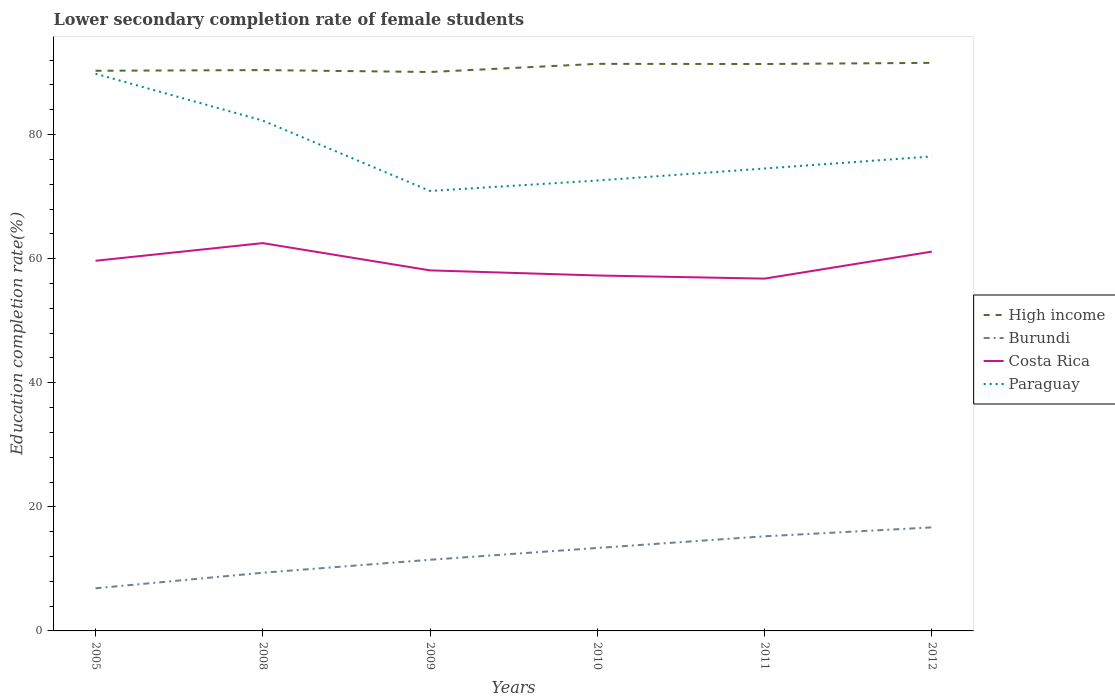How many different coloured lines are there?
Give a very brief answer. 4. Does the line corresponding to Burundi intersect with the line corresponding to High income?
Offer a terse response. No. Is the number of lines equal to the number of legend labels?
Your answer should be compact. Yes. Across all years, what is the maximum lower secondary completion rate of female students in Costa Rica?
Keep it short and to the point. 56.79. In which year was the lower secondary completion rate of female students in Paraguay maximum?
Offer a terse response. 2009. What is the total lower secondary completion rate of female students in Burundi in the graph?
Your answer should be very brief. -3.31. What is the difference between the highest and the second highest lower secondary completion rate of female students in Costa Rica?
Provide a succinct answer. 5.72. What is the difference between the highest and the lowest lower secondary completion rate of female students in Costa Rica?
Ensure brevity in your answer.  3. Is the lower secondary completion rate of female students in High income strictly greater than the lower secondary completion rate of female students in Costa Rica over the years?
Give a very brief answer. No. How many lines are there?
Keep it short and to the point. 4. What is the difference between two consecutive major ticks on the Y-axis?
Ensure brevity in your answer.  20. Does the graph contain any zero values?
Make the answer very short. No. Where does the legend appear in the graph?
Your response must be concise. Center right. How many legend labels are there?
Your answer should be very brief. 4. How are the legend labels stacked?
Your answer should be very brief. Vertical. What is the title of the graph?
Provide a succinct answer. Lower secondary completion rate of female students. Does "Guatemala" appear as one of the legend labels in the graph?
Your answer should be very brief. No. What is the label or title of the Y-axis?
Your response must be concise. Education completion rate(%). What is the Education completion rate(%) in High income in 2005?
Provide a succinct answer. 90.3. What is the Education completion rate(%) of Burundi in 2005?
Your answer should be very brief. 6.87. What is the Education completion rate(%) in Costa Rica in 2005?
Keep it short and to the point. 59.67. What is the Education completion rate(%) in Paraguay in 2005?
Make the answer very short. 89.81. What is the Education completion rate(%) of High income in 2008?
Your answer should be compact. 90.4. What is the Education completion rate(%) in Burundi in 2008?
Ensure brevity in your answer.  9.38. What is the Education completion rate(%) of Costa Rica in 2008?
Make the answer very short. 62.51. What is the Education completion rate(%) in Paraguay in 2008?
Offer a very short reply. 82.26. What is the Education completion rate(%) of High income in 2009?
Keep it short and to the point. 90.1. What is the Education completion rate(%) of Burundi in 2009?
Ensure brevity in your answer.  11.47. What is the Education completion rate(%) of Costa Rica in 2009?
Your answer should be very brief. 58.12. What is the Education completion rate(%) in Paraguay in 2009?
Your response must be concise. 70.92. What is the Education completion rate(%) in High income in 2010?
Your answer should be very brief. 91.41. What is the Education completion rate(%) in Burundi in 2010?
Give a very brief answer. 13.37. What is the Education completion rate(%) of Costa Rica in 2010?
Provide a succinct answer. 57.3. What is the Education completion rate(%) in Paraguay in 2010?
Keep it short and to the point. 72.6. What is the Education completion rate(%) of High income in 2011?
Ensure brevity in your answer.  91.38. What is the Education completion rate(%) of Burundi in 2011?
Provide a short and direct response. 15.25. What is the Education completion rate(%) in Costa Rica in 2011?
Provide a succinct answer. 56.79. What is the Education completion rate(%) in Paraguay in 2011?
Your response must be concise. 74.54. What is the Education completion rate(%) in High income in 2012?
Your response must be concise. 91.57. What is the Education completion rate(%) of Burundi in 2012?
Keep it short and to the point. 16.69. What is the Education completion rate(%) of Costa Rica in 2012?
Offer a very short reply. 61.14. What is the Education completion rate(%) of Paraguay in 2012?
Ensure brevity in your answer.  76.48. Across all years, what is the maximum Education completion rate(%) of High income?
Provide a short and direct response. 91.57. Across all years, what is the maximum Education completion rate(%) of Burundi?
Your answer should be very brief. 16.69. Across all years, what is the maximum Education completion rate(%) in Costa Rica?
Your answer should be very brief. 62.51. Across all years, what is the maximum Education completion rate(%) of Paraguay?
Offer a terse response. 89.81. Across all years, what is the minimum Education completion rate(%) of High income?
Offer a terse response. 90.1. Across all years, what is the minimum Education completion rate(%) in Burundi?
Give a very brief answer. 6.87. Across all years, what is the minimum Education completion rate(%) of Costa Rica?
Make the answer very short. 56.79. Across all years, what is the minimum Education completion rate(%) in Paraguay?
Your answer should be very brief. 70.92. What is the total Education completion rate(%) of High income in the graph?
Keep it short and to the point. 545.16. What is the total Education completion rate(%) of Burundi in the graph?
Offer a very short reply. 73.04. What is the total Education completion rate(%) in Costa Rica in the graph?
Offer a very short reply. 355.52. What is the total Education completion rate(%) in Paraguay in the graph?
Your answer should be compact. 466.62. What is the difference between the Education completion rate(%) of High income in 2005 and that in 2008?
Keep it short and to the point. -0.11. What is the difference between the Education completion rate(%) in Burundi in 2005 and that in 2008?
Offer a terse response. -2.5. What is the difference between the Education completion rate(%) of Costa Rica in 2005 and that in 2008?
Offer a very short reply. -2.84. What is the difference between the Education completion rate(%) in Paraguay in 2005 and that in 2008?
Provide a succinct answer. 7.55. What is the difference between the Education completion rate(%) in High income in 2005 and that in 2009?
Provide a succinct answer. 0.2. What is the difference between the Education completion rate(%) in Burundi in 2005 and that in 2009?
Provide a succinct answer. -4.6. What is the difference between the Education completion rate(%) in Costa Rica in 2005 and that in 2009?
Make the answer very short. 1.55. What is the difference between the Education completion rate(%) of Paraguay in 2005 and that in 2009?
Your response must be concise. 18.89. What is the difference between the Education completion rate(%) in High income in 2005 and that in 2010?
Offer a terse response. -1.11. What is the difference between the Education completion rate(%) in Burundi in 2005 and that in 2010?
Your answer should be compact. -6.5. What is the difference between the Education completion rate(%) in Costa Rica in 2005 and that in 2010?
Your answer should be compact. 2.37. What is the difference between the Education completion rate(%) of Paraguay in 2005 and that in 2010?
Make the answer very short. 17.21. What is the difference between the Education completion rate(%) in High income in 2005 and that in 2011?
Ensure brevity in your answer.  -1.09. What is the difference between the Education completion rate(%) in Burundi in 2005 and that in 2011?
Ensure brevity in your answer.  -8.38. What is the difference between the Education completion rate(%) in Costa Rica in 2005 and that in 2011?
Ensure brevity in your answer.  2.88. What is the difference between the Education completion rate(%) in Paraguay in 2005 and that in 2011?
Your response must be concise. 15.27. What is the difference between the Education completion rate(%) of High income in 2005 and that in 2012?
Provide a succinct answer. -1.27. What is the difference between the Education completion rate(%) in Burundi in 2005 and that in 2012?
Offer a terse response. -9.81. What is the difference between the Education completion rate(%) of Costa Rica in 2005 and that in 2012?
Offer a very short reply. -1.47. What is the difference between the Education completion rate(%) in Paraguay in 2005 and that in 2012?
Offer a terse response. 13.33. What is the difference between the Education completion rate(%) of High income in 2008 and that in 2009?
Keep it short and to the point. 0.31. What is the difference between the Education completion rate(%) in Burundi in 2008 and that in 2009?
Make the answer very short. -2.09. What is the difference between the Education completion rate(%) of Costa Rica in 2008 and that in 2009?
Provide a succinct answer. 4.39. What is the difference between the Education completion rate(%) in Paraguay in 2008 and that in 2009?
Your answer should be compact. 11.34. What is the difference between the Education completion rate(%) of High income in 2008 and that in 2010?
Make the answer very short. -1.01. What is the difference between the Education completion rate(%) of Burundi in 2008 and that in 2010?
Give a very brief answer. -4. What is the difference between the Education completion rate(%) of Costa Rica in 2008 and that in 2010?
Your answer should be compact. 5.22. What is the difference between the Education completion rate(%) in Paraguay in 2008 and that in 2010?
Make the answer very short. 9.66. What is the difference between the Education completion rate(%) of High income in 2008 and that in 2011?
Keep it short and to the point. -0.98. What is the difference between the Education completion rate(%) of Burundi in 2008 and that in 2011?
Offer a very short reply. -5.88. What is the difference between the Education completion rate(%) of Costa Rica in 2008 and that in 2011?
Your answer should be compact. 5.72. What is the difference between the Education completion rate(%) in Paraguay in 2008 and that in 2011?
Provide a succinct answer. 7.72. What is the difference between the Education completion rate(%) in High income in 2008 and that in 2012?
Offer a terse response. -1.17. What is the difference between the Education completion rate(%) in Burundi in 2008 and that in 2012?
Provide a succinct answer. -7.31. What is the difference between the Education completion rate(%) of Costa Rica in 2008 and that in 2012?
Ensure brevity in your answer.  1.37. What is the difference between the Education completion rate(%) in Paraguay in 2008 and that in 2012?
Provide a succinct answer. 5.78. What is the difference between the Education completion rate(%) in High income in 2009 and that in 2010?
Keep it short and to the point. -1.31. What is the difference between the Education completion rate(%) in Burundi in 2009 and that in 2010?
Your response must be concise. -1.9. What is the difference between the Education completion rate(%) of Costa Rica in 2009 and that in 2010?
Your answer should be very brief. 0.82. What is the difference between the Education completion rate(%) in Paraguay in 2009 and that in 2010?
Make the answer very short. -1.68. What is the difference between the Education completion rate(%) in High income in 2009 and that in 2011?
Offer a very short reply. -1.29. What is the difference between the Education completion rate(%) in Burundi in 2009 and that in 2011?
Provide a short and direct response. -3.78. What is the difference between the Education completion rate(%) in Costa Rica in 2009 and that in 2011?
Your response must be concise. 1.33. What is the difference between the Education completion rate(%) in Paraguay in 2009 and that in 2011?
Offer a very short reply. -3.62. What is the difference between the Education completion rate(%) in High income in 2009 and that in 2012?
Ensure brevity in your answer.  -1.48. What is the difference between the Education completion rate(%) in Burundi in 2009 and that in 2012?
Your answer should be compact. -5.22. What is the difference between the Education completion rate(%) of Costa Rica in 2009 and that in 2012?
Offer a very short reply. -3.02. What is the difference between the Education completion rate(%) in Paraguay in 2009 and that in 2012?
Your response must be concise. -5.56. What is the difference between the Education completion rate(%) of High income in 2010 and that in 2011?
Offer a very short reply. 0.03. What is the difference between the Education completion rate(%) in Burundi in 2010 and that in 2011?
Your answer should be very brief. -1.88. What is the difference between the Education completion rate(%) of Costa Rica in 2010 and that in 2011?
Keep it short and to the point. 0.51. What is the difference between the Education completion rate(%) in Paraguay in 2010 and that in 2011?
Provide a succinct answer. -1.94. What is the difference between the Education completion rate(%) in High income in 2010 and that in 2012?
Offer a terse response. -0.16. What is the difference between the Education completion rate(%) in Burundi in 2010 and that in 2012?
Offer a terse response. -3.31. What is the difference between the Education completion rate(%) in Costa Rica in 2010 and that in 2012?
Keep it short and to the point. -3.85. What is the difference between the Education completion rate(%) in Paraguay in 2010 and that in 2012?
Provide a succinct answer. -3.88. What is the difference between the Education completion rate(%) in High income in 2011 and that in 2012?
Give a very brief answer. -0.19. What is the difference between the Education completion rate(%) in Burundi in 2011 and that in 2012?
Your answer should be very brief. -1.43. What is the difference between the Education completion rate(%) in Costa Rica in 2011 and that in 2012?
Your answer should be compact. -4.35. What is the difference between the Education completion rate(%) in Paraguay in 2011 and that in 2012?
Give a very brief answer. -1.94. What is the difference between the Education completion rate(%) of High income in 2005 and the Education completion rate(%) of Burundi in 2008?
Keep it short and to the point. 80.92. What is the difference between the Education completion rate(%) of High income in 2005 and the Education completion rate(%) of Costa Rica in 2008?
Your answer should be very brief. 27.79. What is the difference between the Education completion rate(%) of High income in 2005 and the Education completion rate(%) of Paraguay in 2008?
Provide a succinct answer. 8.03. What is the difference between the Education completion rate(%) in Burundi in 2005 and the Education completion rate(%) in Costa Rica in 2008?
Make the answer very short. -55.64. What is the difference between the Education completion rate(%) in Burundi in 2005 and the Education completion rate(%) in Paraguay in 2008?
Provide a short and direct response. -75.39. What is the difference between the Education completion rate(%) in Costa Rica in 2005 and the Education completion rate(%) in Paraguay in 2008?
Provide a short and direct response. -22.6. What is the difference between the Education completion rate(%) in High income in 2005 and the Education completion rate(%) in Burundi in 2009?
Make the answer very short. 78.83. What is the difference between the Education completion rate(%) of High income in 2005 and the Education completion rate(%) of Costa Rica in 2009?
Your answer should be compact. 32.18. What is the difference between the Education completion rate(%) of High income in 2005 and the Education completion rate(%) of Paraguay in 2009?
Your answer should be very brief. 19.37. What is the difference between the Education completion rate(%) in Burundi in 2005 and the Education completion rate(%) in Costa Rica in 2009?
Make the answer very short. -51.24. What is the difference between the Education completion rate(%) in Burundi in 2005 and the Education completion rate(%) in Paraguay in 2009?
Provide a succinct answer. -64.05. What is the difference between the Education completion rate(%) in Costa Rica in 2005 and the Education completion rate(%) in Paraguay in 2009?
Your answer should be compact. -11.26. What is the difference between the Education completion rate(%) in High income in 2005 and the Education completion rate(%) in Burundi in 2010?
Make the answer very short. 76.92. What is the difference between the Education completion rate(%) of High income in 2005 and the Education completion rate(%) of Costa Rica in 2010?
Keep it short and to the point. 33. What is the difference between the Education completion rate(%) of High income in 2005 and the Education completion rate(%) of Paraguay in 2010?
Your answer should be very brief. 17.69. What is the difference between the Education completion rate(%) in Burundi in 2005 and the Education completion rate(%) in Costa Rica in 2010?
Ensure brevity in your answer.  -50.42. What is the difference between the Education completion rate(%) in Burundi in 2005 and the Education completion rate(%) in Paraguay in 2010?
Your answer should be compact. -65.73. What is the difference between the Education completion rate(%) in Costa Rica in 2005 and the Education completion rate(%) in Paraguay in 2010?
Offer a terse response. -12.93. What is the difference between the Education completion rate(%) in High income in 2005 and the Education completion rate(%) in Burundi in 2011?
Provide a succinct answer. 75.04. What is the difference between the Education completion rate(%) in High income in 2005 and the Education completion rate(%) in Costa Rica in 2011?
Your response must be concise. 33.51. What is the difference between the Education completion rate(%) of High income in 2005 and the Education completion rate(%) of Paraguay in 2011?
Make the answer very short. 15.76. What is the difference between the Education completion rate(%) in Burundi in 2005 and the Education completion rate(%) in Costa Rica in 2011?
Your answer should be very brief. -49.91. What is the difference between the Education completion rate(%) in Burundi in 2005 and the Education completion rate(%) in Paraguay in 2011?
Your answer should be very brief. -67.67. What is the difference between the Education completion rate(%) of Costa Rica in 2005 and the Education completion rate(%) of Paraguay in 2011?
Your answer should be very brief. -14.87. What is the difference between the Education completion rate(%) of High income in 2005 and the Education completion rate(%) of Burundi in 2012?
Your answer should be compact. 73.61. What is the difference between the Education completion rate(%) of High income in 2005 and the Education completion rate(%) of Costa Rica in 2012?
Keep it short and to the point. 29.15. What is the difference between the Education completion rate(%) in High income in 2005 and the Education completion rate(%) in Paraguay in 2012?
Provide a short and direct response. 13.81. What is the difference between the Education completion rate(%) in Burundi in 2005 and the Education completion rate(%) in Costa Rica in 2012?
Provide a short and direct response. -54.27. What is the difference between the Education completion rate(%) of Burundi in 2005 and the Education completion rate(%) of Paraguay in 2012?
Give a very brief answer. -69.61. What is the difference between the Education completion rate(%) in Costa Rica in 2005 and the Education completion rate(%) in Paraguay in 2012?
Make the answer very short. -16.81. What is the difference between the Education completion rate(%) of High income in 2008 and the Education completion rate(%) of Burundi in 2009?
Offer a very short reply. 78.93. What is the difference between the Education completion rate(%) of High income in 2008 and the Education completion rate(%) of Costa Rica in 2009?
Your answer should be very brief. 32.29. What is the difference between the Education completion rate(%) of High income in 2008 and the Education completion rate(%) of Paraguay in 2009?
Your answer should be very brief. 19.48. What is the difference between the Education completion rate(%) of Burundi in 2008 and the Education completion rate(%) of Costa Rica in 2009?
Offer a terse response. -48.74. What is the difference between the Education completion rate(%) in Burundi in 2008 and the Education completion rate(%) in Paraguay in 2009?
Keep it short and to the point. -61.55. What is the difference between the Education completion rate(%) of Costa Rica in 2008 and the Education completion rate(%) of Paraguay in 2009?
Ensure brevity in your answer.  -8.41. What is the difference between the Education completion rate(%) in High income in 2008 and the Education completion rate(%) in Burundi in 2010?
Your answer should be compact. 77.03. What is the difference between the Education completion rate(%) in High income in 2008 and the Education completion rate(%) in Costa Rica in 2010?
Your response must be concise. 33.11. What is the difference between the Education completion rate(%) in High income in 2008 and the Education completion rate(%) in Paraguay in 2010?
Give a very brief answer. 17.8. What is the difference between the Education completion rate(%) in Burundi in 2008 and the Education completion rate(%) in Costa Rica in 2010?
Offer a very short reply. -47.92. What is the difference between the Education completion rate(%) of Burundi in 2008 and the Education completion rate(%) of Paraguay in 2010?
Your response must be concise. -63.22. What is the difference between the Education completion rate(%) in Costa Rica in 2008 and the Education completion rate(%) in Paraguay in 2010?
Provide a short and direct response. -10.09. What is the difference between the Education completion rate(%) of High income in 2008 and the Education completion rate(%) of Burundi in 2011?
Your answer should be very brief. 75.15. What is the difference between the Education completion rate(%) of High income in 2008 and the Education completion rate(%) of Costa Rica in 2011?
Give a very brief answer. 33.62. What is the difference between the Education completion rate(%) in High income in 2008 and the Education completion rate(%) in Paraguay in 2011?
Make the answer very short. 15.86. What is the difference between the Education completion rate(%) of Burundi in 2008 and the Education completion rate(%) of Costa Rica in 2011?
Provide a succinct answer. -47.41. What is the difference between the Education completion rate(%) of Burundi in 2008 and the Education completion rate(%) of Paraguay in 2011?
Provide a short and direct response. -65.16. What is the difference between the Education completion rate(%) of Costa Rica in 2008 and the Education completion rate(%) of Paraguay in 2011?
Offer a terse response. -12.03. What is the difference between the Education completion rate(%) in High income in 2008 and the Education completion rate(%) in Burundi in 2012?
Provide a succinct answer. 73.72. What is the difference between the Education completion rate(%) of High income in 2008 and the Education completion rate(%) of Costa Rica in 2012?
Ensure brevity in your answer.  29.26. What is the difference between the Education completion rate(%) in High income in 2008 and the Education completion rate(%) in Paraguay in 2012?
Ensure brevity in your answer.  13.92. What is the difference between the Education completion rate(%) in Burundi in 2008 and the Education completion rate(%) in Costa Rica in 2012?
Provide a short and direct response. -51.76. What is the difference between the Education completion rate(%) of Burundi in 2008 and the Education completion rate(%) of Paraguay in 2012?
Provide a short and direct response. -67.1. What is the difference between the Education completion rate(%) in Costa Rica in 2008 and the Education completion rate(%) in Paraguay in 2012?
Provide a short and direct response. -13.97. What is the difference between the Education completion rate(%) of High income in 2009 and the Education completion rate(%) of Burundi in 2010?
Offer a very short reply. 76.72. What is the difference between the Education completion rate(%) in High income in 2009 and the Education completion rate(%) in Costa Rica in 2010?
Keep it short and to the point. 32.8. What is the difference between the Education completion rate(%) in High income in 2009 and the Education completion rate(%) in Paraguay in 2010?
Offer a very short reply. 17.49. What is the difference between the Education completion rate(%) of Burundi in 2009 and the Education completion rate(%) of Costa Rica in 2010?
Keep it short and to the point. -45.83. What is the difference between the Education completion rate(%) in Burundi in 2009 and the Education completion rate(%) in Paraguay in 2010?
Provide a succinct answer. -61.13. What is the difference between the Education completion rate(%) of Costa Rica in 2009 and the Education completion rate(%) of Paraguay in 2010?
Provide a short and direct response. -14.48. What is the difference between the Education completion rate(%) in High income in 2009 and the Education completion rate(%) in Burundi in 2011?
Ensure brevity in your answer.  74.84. What is the difference between the Education completion rate(%) in High income in 2009 and the Education completion rate(%) in Costa Rica in 2011?
Your response must be concise. 33.31. What is the difference between the Education completion rate(%) in High income in 2009 and the Education completion rate(%) in Paraguay in 2011?
Your answer should be very brief. 15.56. What is the difference between the Education completion rate(%) of Burundi in 2009 and the Education completion rate(%) of Costa Rica in 2011?
Give a very brief answer. -45.32. What is the difference between the Education completion rate(%) in Burundi in 2009 and the Education completion rate(%) in Paraguay in 2011?
Offer a very short reply. -63.07. What is the difference between the Education completion rate(%) in Costa Rica in 2009 and the Education completion rate(%) in Paraguay in 2011?
Your answer should be compact. -16.42. What is the difference between the Education completion rate(%) of High income in 2009 and the Education completion rate(%) of Burundi in 2012?
Offer a terse response. 73.41. What is the difference between the Education completion rate(%) of High income in 2009 and the Education completion rate(%) of Costa Rica in 2012?
Your answer should be very brief. 28.95. What is the difference between the Education completion rate(%) of High income in 2009 and the Education completion rate(%) of Paraguay in 2012?
Keep it short and to the point. 13.61. What is the difference between the Education completion rate(%) of Burundi in 2009 and the Education completion rate(%) of Costa Rica in 2012?
Your response must be concise. -49.67. What is the difference between the Education completion rate(%) in Burundi in 2009 and the Education completion rate(%) in Paraguay in 2012?
Your response must be concise. -65.01. What is the difference between the Education completion rate(%) of Costa Rica in 2009 and the Education completion rate(%) of Paraguay in 2012?
Your answer should be compact. -18.36. What is the difference between the Education completion rate(%) in High income in 2010 and the Education completion rate(%) in Burundi in 2011?
Provide a succinct answer. 76.16. What is the difference between the Education completion rate(%) in High income in 2010 and the Education completion rate(%) in Costa Rica in 2011?
Offer a terse response. 34.62. What is the difference between the Education completion rate(%) of High income in 2010 and the Education completion rate(%) of Paraguay in 2011?
Keep it short and to the point. 16.87. What is the difference between the Education completion rate(%) of Burundi in 2010 and the Education completion rate(%) of Costa Rica in 2011?
Your answer should be compact. -43.41. What is the difference between the Education completion rate(%) in Burundi in 2010 and the Education completion rate(%) in Paraguay in 2011?
Provide a short and direct response. -61.17. What is the difference between the Education completion rate(%) in Costa Rica in 2010 and the Education completion rate(%) in Paraguay in 2011?
Your answer should be compact. -17.24. What is the difference between the Education completion rate(%) of High income in 2010 and the Education completion rate(%) of Burundi in 2012?
Make the answer very short. 74.72. What is the difference between the Education completion rate(%) of High income in 2010 and the Education completion rate(%) of Costa Rica in 2012?
Your response must be concise. 30.27. What is the difference between the Education completion rate(%) in High income in 2010 and the Education completion rate(%) in Paraguay in 2012?
Ensure brevity in your answer.  14.93. What is the difference between the Education completion rate(%) in Burundi in 2010 and the Education completion rate(%) in Costa Rica in 2012?
Ensure brevity in your answer.  -47.77. What is the difference between the Education completion rate(%) of Burundi in 2010 and the Education completion rate(%) of Paraguay in 2012?
Your answer should be very brief. -63.11. What is the difference between the Education completion rate(%) of Costa Rica in 2010 and the Education completion rate(%) of Paraguay in 2012?
Your answer should be very brief. -19.19. What is the difference between the Education completion rate(%) of High income in 2011 and the Education completion rate(%) of Burundi in 2012?
Keep it short and to the point. 74.69. What is the difference between the Education completion rate(%) in High income in 2011 and the Education completion rate(%) in Costa Rica in 2012?
Make the answer very short. 30.24. What is the difference between the Education completion rate(%) of High income in 2011 and the Education completion rate(%) of Paraguay in 2012?
Your answer should be very brief. 14.9. What is the difference between the Education completion rate(%) of Burundi in 2011 and the Education completion rate(%) of Costa Rica in 2012?
Offer a terse response. -45.89. What is the difference between the Education completion rate(%) of Burundi in 2011 and the Education completion rate(%) of Paraguay in 2012?
Your response must be concise. -61.23. What is the difference between the Education completion rate(%) of Costa Rica in 2011 and the Education completion rate(%) of Paraguay in 2012?
Provide a short and direct response. -19.69. What is the average Education completion rate(%) in High income per year?
Your answer should be compact. 90.86. What is the average Education completion rate(%) of Burundi per year?
Give a very brief answer. 12.17. What is the average Education completion rate(%) of Costa Rica per year?
Give a very brief answer. 59.25. What is the average Education completion rate(%) in Paraguay per year?
Your answer should be compact. 77.77. In the year 2005, what is the difference between the Education completion rate(%) of High income and Education completion rate(%) of Burundi?
Your response must be concise. 83.42. In the year 2005, what is the difference between the Education completion rate(%) in High income and Education completion rate(%) in Costa Rica?
Ensure brevity in your answer.  30.63. In the year 2005, what is the difference between the Education completion rate(%) of High income and Education completion rate(%) of Paraguay?
Offer a terse response. 0.48. In the year 2005, what is the difference between the Education completion rate(%) of Burundi and Education completion rate(%) of Costa Rica?
Offer a terse response. -52.79. In the year 2005, what is the difference between the Education completion rate(%) in Burundi and Education completion rate(%) in Paraguay?
Offer a terse response. -82.94. In the year 2005, what is the difference between the Education completion rate(%) of Costa Rica and Education completion rate(%) of Paraguay?
Your answer should be very brief. -30.14. In the year 2008, what is the difference between the Education completion rate(%) of High income and Education completion rate(%) of Burundi?
Your answer should be very brief. 81.03. In the year 2008, what is the difference between the Education completion rate(%) in High income and Education completion rate(%) in Costa Rica?
Give a very brief answer. 27.89. In the year 2008, what is the difference between the Education completion rate(%) of High income and Education completion rate(%) of Paraguay?
Provide a short and direct response. 8.14. In the year 2008, what is the difference between the Education completion rate(%) of Burundi and Education completion rate(%) of Costa Rica?
Provide a succinct answer. -53.13. In the year 2008, what is the difference between the Education completion rate(%) of Burundi and Education completion rate(%) of Paraguay?
Offer a terse response. -72.89. In the year 2008, what is the difference between the Education completion rate(%) in Costa Rica and Education completion rate(%) in Paraguay?
Offer a very short reply. -19.75. In the year 2009, what is the difference between the Education completion rate(%) in High income and Education completion rate(%) in Burundi?
Your response must be concise. 78.63. In the year 2009, what is the difference between the Education completion rate(%) in High income and Education completion rate(%) in Costa Rica?
Offer a terse response. 31.98. In the year 2009, what is the difference between the Education completion rate(%) in High income and Education completion rate(%) in Paraguay?
Keep it short and to the point. 19.17. In the year 2009, what is the difference between the Education completion rate(%) in Burundi and Education completion rate(%) in Costa Rica?
Your answer should be compact. -46.65. In the year 2009, what is the difference between the Education completion rate(%) of Burundi and Education completion rate(%) of Paraguay?
Give a very brief answer. -59.45. In the year 2009, what is the difference between the Education completion rate(%) in Costa Rica and Education completion rate(%) in Paraguay?
Provide a short and direct response. -12.81. In the year 2010, what is the difference between the Education completion rate(%) in High income and Education completion rate(%) in Burundi?
Make the answer very short. 78.04. In the year 2010, what is the difference between the Education completion rate(%) of High income and Education completion rate(%) of Costa Rica?
Your answer should be very brief. 34.12. In the year 2010, what is the difference between the Education completion rate(%) of High income and Education completion rate(%) of Paraguay?
Provide a succinct answer. 18.81. In the year 2010, what is the difference between the Education completion rate(%) in Burundi and Education completion rate(%) in Costa Rica?
Keep it short and to the point. -43.92. In the year 2010, what is the difference between the Education completion rate(%) in Burundi and Education completion rate(%) in Paraguay?
Offer a very short reply. -59.23. In the year 2010, what is the difference between the Education completion rate(%) of Costa Rica and Education completion rate(%) of Paraguay?
Provide a short and direct response. -15.31. In the year 2011, what is the difference between the Education completion rate(%) of High income and Education completion rate(%) of Burundi?
Give a very brief answer. 76.13. In the year 2011, what is the difference between the Education completion rate(%) of High income and Education completion rate(%) of Costa Rica?
Your answer should be compact. 34.59. In the year 2011, what is the difference between the Education completion rate(%) in High income and Education completion rate(%) in Paraguay?
Your answer should be compact. 16.84. In the year 2011, what is the difference between the Education completion rate(%) in Burundi and Education completion rate(%) in Costa Rica?
Your answer should be compact. -41.53. In the year 2011, what is the difference between the Education completion rate(%) in Burundi and Education completion rate(%) in Paraguay?
Offer a very short reply. -59.29. In the year 2011, what is the difference between the Education completion rate(%) of Costa Rica and Education completion rate(%) of Paraguay?
Make the answer very short. -17.75. In the year 2012, what is the difference between the Education completion rate(%) of High income and Education completion rate(%) of Burundi?
Your response must be concise. 74.88. In the year 2012, what is the difference between the Education completion rate(%) of High income and Education completion rate(%) of Costa Rica?
Your answer should be compact. 30.43. In the year 2012, what is the difference between the Education completion rate(%) of High income and Education completion rate(%) of Paraguay?
Provide a succinct answer. 15.09. In the year 2012, what is the difference between the Education completion rate(%) of Burundi and Education completion rate(%) of Costa Rica?
Offer a very short reply. -44.45. In the year 2012, what is the difference between the Education completion rate(%) in Burundi and Education completion rate(%) in Paraguay?
Your answer should be very brief. -59.79. In the year 2012, what is the difference between the Education completion rate(%) in Costa Rica and Education completion rate(%) in Paraguay?
Your response must be concise. -15.34. What is the ratio of the Education completion rate(%) of High income in 2005 to that in 2008?
Provide a short and direct response. 1. What is the ratio of the Education completion rate(%) of Burundi in 2005 to that in 2008?
Your answer should be very brief. 0.73. What is the ratio of the Education completion rate(%) in Costa Rica in 2005 to that in 2008?
Your answer should be compact. 0.95. What is the ratio of the Education completion rate(%) of Paraguay in 2005 to that in 2008?
Your answer should be very brief. 1.09. What is the ratio of the Education completion rate(%) in High income in 2005 to that in 2009?
Offer a terse response. 1. What is the ratio of the Education completion rate(%) in Burundi in 2005 to that in 2009?
Give a very brief answer. 0.6. What is the ratio of the Education completion rate(%) in Costa Rica in 2005 to that in 2009?
Provide a succinct answer. 1.03. What is the ratio of the Education completion rate(%) in Paraguay in 2005 to that in 2009?
Offer a very short reply. 1.27. What is the ratio of the Education completion rate(%) in Burundi in 2005 to that in 2010?
Provide a short and direct response. 0.51. What is the ratio of the Education completion rate(%) in Costa Rica in 2005 to that in 2010?
Provide a short and direct response. 1.04. What is the ratio of the Education completion rate(%) in Paraguay in 2005 to that in 2010?
Offer a very short reply. 1.24. What is the ratio of the Education completion rate(%) in Burundi in 2005 to that in 2011?
Give a very brief answer. 0.45. What is the ratio of the Education completion rate(%) of Costa Rica in 2005 to that in 2011?
Ensure brevity in your answer.  1.05. What is the ratio of the Education completion rate(%) of Paraguay in 2005 to that in 2011?
Provide a short and direct response. 1.2. What is the ratio of the Education completion rate(%) of High income in 2005 to that in 2012?
Make the answer very short. 0.99. What is the ratio of the Education completion rate(%) of Burundi in 2005 to that in 2012?
Make the answer very short. 0.41. What is the ratio of the Education completion rate(%) in Costa Rica in 2005 to that in 2012?
Your response must be concise. 0.98. What is the ratio of the Education completion rate(%) of Paraguay in 2005 to that in 2012?
Provide a succinct answer. 1.17. What is the ratio of the Education completion rate(%) of High income in 2008 to that in 2009?
Make the answer very short. 1. What is the ratio of the Education completion rate(%) in Burundi in 2008 to that in 2009?
Offer a terse response. 0.82. What is the ratio of the Education completion rate(%) in Costa Rica in 2008 to that in 2009?
Make the answer very short. 1.08. What is the ratio of the Education completion rate(%) of Paraguay in 2008 to that in 2009?
Keep it short and to the point. 1.16. What is the ratio of the Education completion rate(%) in Burundi in 2008 to that in 2010?
Keep it short and to the point. 0.7. What is the ratio of the Education completion rate(%) of Costa Rica in 2008 to that in 2010?
Your answer should be compact. 1.09. What is the ratio of the Education completion rate(%) of Paraguay in 2008 to that in 2010?
Provide a short and direct response. 1.13. What is the ratio of the Education completion rate(%) of High income in 2008 to that in 2011?
Make the answer very short. 0.99. What is the ratio of the Education completion rate(%) in Burundi in 2008 to that in 2011?
Give a very brief answer. 0.61. What is the ratio of the Education completion rate(%) in Costa Rica in 2008 to that in 2011?
Make the answer very short. 1.1. What is the ratio of the Education completion rate(%) in Paraguay in 2008 to that in 2011?
Give a very brief answer. 1.1. What is the ratio of the Education completion rate(%) in High income in 2008 to that in 2012?
Offer a terse response. 0.99. What is the ratio of the Education completion rate(%) in Burundi in 2008 to that in 2012?
Provide a short and direct response. 0.56. What is the ratio of the Education completion rate(%) in Costa Rica in 2008 to that in 2012?
Offer a very short reply. 1.02. What is the ratio of the Education completion rate(%) in Paraguay in 2008 to that in 2012?
Offer a very short reply. 1.08. What is the ratio of the Education completion rate(%) of High income in 2009 to that in 2010?
Keep it short and to the point. 0.99. What is the ratio of the Education completion rate(%) in Burundi in 2009 to that in 2010?
Keep it short and to the point. 0.86. What is the ratio of the Education completion rate(%) of Costa Rica in 2009 to that in 2010?
Your response must be concise. 1.01. What is the ratio of the Education completion rate(%) in Paraguay in 2009 to that in 2010?
Offer a terse response. 0.98. What is the ratio of the Education completion rate(%) in High income in 2009 to that in 2011?
Make the answer very short. 0.99. What is the ratio of the Education completion rate(%) in Burundi in 2009 to that in 2011?
Keep it short and to the point. 0.75. What is the ratio of the Education completion rate(%) in Costa Rica in 2009 to that in 2011?
Keep it short and to the point. 1.02. What is the ratio of the Education completion rate(%) in Paraguay in 2009 to that in 2011?
Offer a terse response. 0.95. What is the ratio of the Education completion rate(%) of High income in 2009 to that in 2012?
Keep it short and to the point. 0.98. What is the ratio of the Education completion rate(%) in Burundi in 2009 to that in 2012?
Ensure brevity in your answer.  0.69. What is the ratio of the Education completion rate(%) in Costa Rica in 2009 to that in 2012?
Keep it short and to the point. 0.95. What is the ratio of the Education completion rate(%) of Paraguay in 2009 to that in 2012?
Your answer should be very brief. 0.93. What is the ratio of the Education completion rate(%) in High income in 2010 to that in 2011?
Ensure brevity in your answer.  1. What is the ratio of the Education completion rate(%) in Burundi in 2010 to that in 2011?
Make the answer very short. 0.88. What is the ratio of the Education completion rate(%) in Costa Rica in 2010 to that in 2011?
Provide a short and direct response. 1.01. What is the ratio of the Education completion rate(%) in Paraguay in 2010 to that in 2011?
Make the answer very short. 0.97. What is the ratio of the Education completion rate(%) in Burundi in 2010 to that in 2012?
Keep it short and to the point. 0.8. What is the ratio of the Education completion rate(%) in Costa Rica in 2010 to that in 2012?
Offer a very short reply. 0.94. What is the ratio of the Education completion rate(%) in Paraguay in 2010 to that in 2012?
Make the answer very short. 0.95. What is the ratio of the Education completion rate(%) in Burundi in 2011 to that in 2012?
Offer a terse response. 0.91. What is the ratio of the Education completion rate(%) in Costa Rica in 2011 to that in 2012?
Provide a short and direct response. 0.93. What is the ratio of the Education completion rate(%) in Paraguay in 2011 to that in 2012?
Give a very brief answer. 0.97. What is the difference between the highest and the second highest Education completion rate(%) in High income?
Your answer should be compact. 0.16. What is the difference between the highest and the second highest Education completion rate(%) in Burundi?
Make the answer very short. 1.43. What is the difference between the highest and the second highest Education completion rate(%) in Costa Rica?
Give a very brief answer. 1.37. What is the difference between the highest and the second highest Education completion rate(%) in Paraguay?
Your answer should be compact. 7.55. What is the difference between the highest and the lowest Education completion rate(%) in High income?
Ensure brevity in your answer.  1.48. What is the difference between the highest and the lowest Education completion rate(%) in Burundi?
Provide a short and direct response. 9.81. What is the difference between the highest and the lowest Education completion rate(%) in Costa Rica?
Your answer should be compact. 5.72. What is the difference between the highest and the lowest Education completion rate(%) in Paraguay?
Keep it short and to the point. 18.89. 